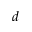<formula> <loc_0><loc_0><loc_500><loc_500>d</formula> 